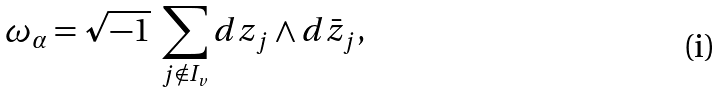<formula> <loc_0><loc_0><loc_500><loc_500>\omega _ { \alpha } = \sqrt { - 1 } \ \sum _ { j \notin I _ { v } } d z _ { j } \wedge d \bar { z } _ { j } ,</formula> 